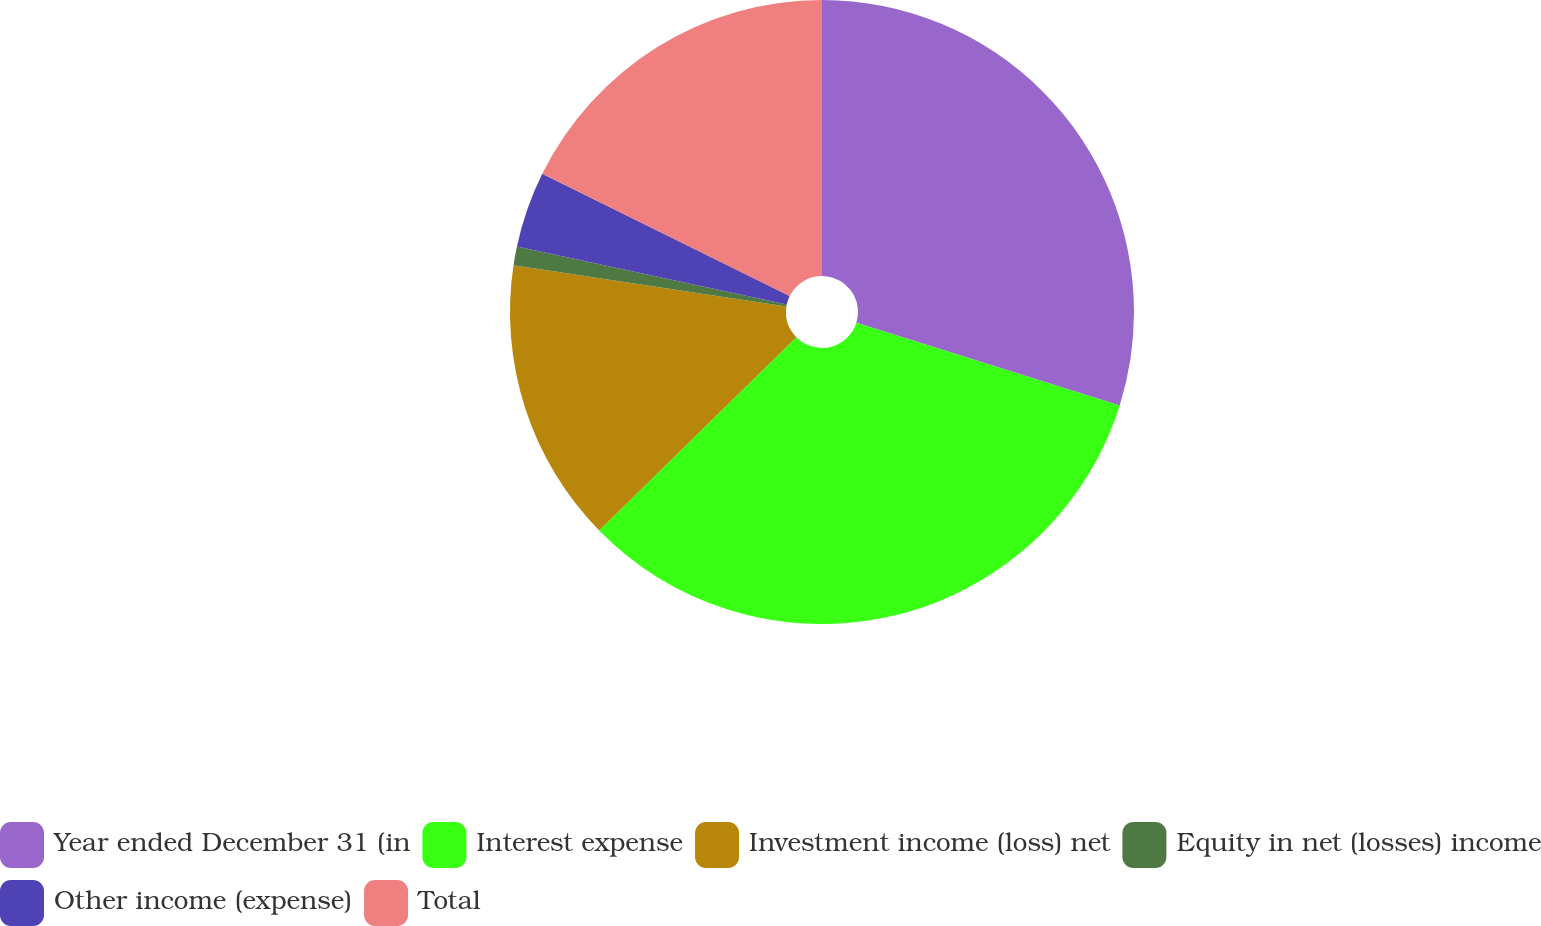<chart> <loc_0><loc_0><loc_500><loc_500><pie_chart><fcel>Year ended December 31 (in<fcel>Interest expense<fcel>Investment income (loss) net<fcel>Equity in net (losses) income<fcel>Other income (expense)<fcel>Total<nl><fcel>29.84%<fcel>32.82%<fcel>14.73%<fcel>0.97%<fcel>3.94%<fcel>17.7%<nl></chart> 